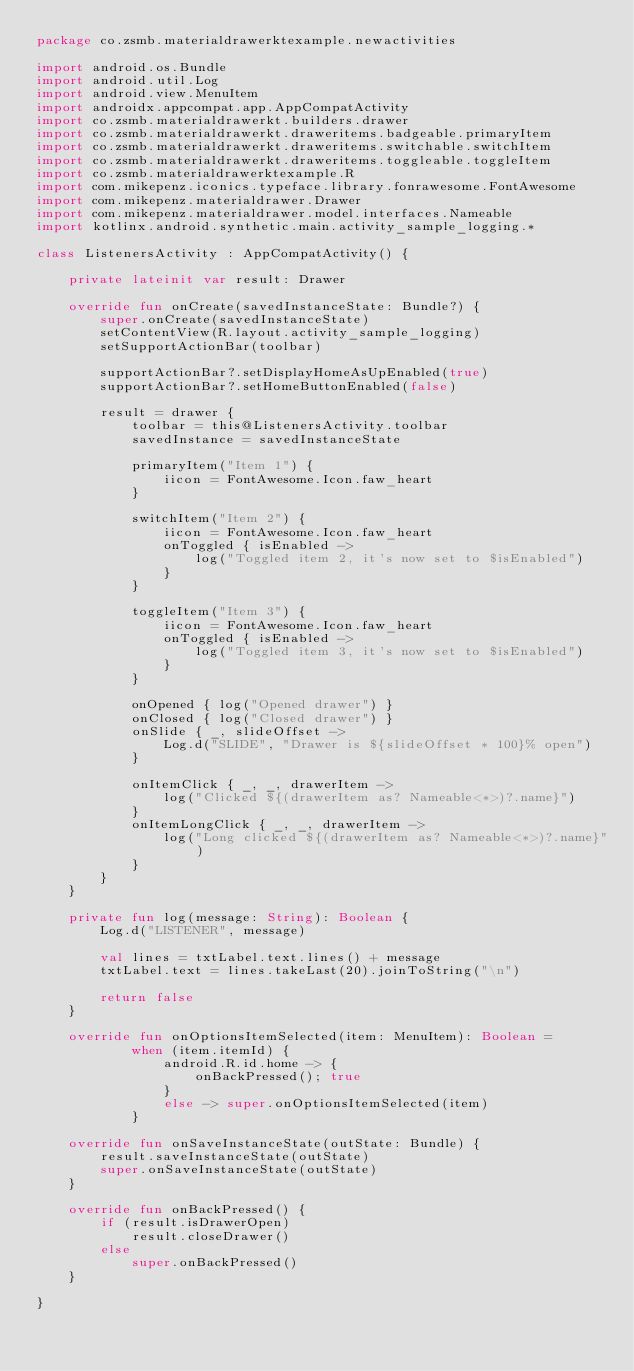Convert code to text. <code><loc_0><loc_0><loc_500><loc_500><_Kotlin_>package co.zsmb.materialdrawerktexample.newactivities

import android.os.Bundle
import android.util.Log
import android.view.MenuItem
import androidx.appcompat.app.AppCompatActivity
import co.zsmb.materialdrawerkt.builders.drawer
import co.zsmb.materialdrawerkt.draweritems.badgeable.primaryItem
import co.zsmb.materialdrawerkt.draweritems.switchable.switchItem
import co.zsmb.materialdrawerkt.draweritems.toggleable.toggleItem
import co.zsmb.materialdrawerktexample.R
import com.mikepenz.iconics.typeface.library.fonrawesome.FontAwesome
import com.mikepenz.materialdrawer.Drawer
import com.mikepenz.materialdrawer.model.interfaces.Nameable
import kotlinx.android.synthetic.main.activity_sample_logging.*

class ListenersActivity : AppCompatActivity() {

    private lateinit var result: Drawer

    override fun onCreate(savedInstanceState: Bundle?) {
        super.onCreate(savedInstanceState)
        setContentView(R.layout.activity_sample_logging)
        setSupportActionBar(toolbar)

        supportActionBar?.setDisplayHomeAsUpEnabled(true)
        supportActionBar?.setHomeButtonEnabled(false)

        result = drawer {
            toolbar = this@ListenersActivity.toolbar
            savedInstance = savedInstanceState

            primaryItem("Item 1") {
                iicon = FontAwesome.Icon.faw_heart
            }

            switchItem("Item 2") {
                iicon = FontAwesome.Icon.faw_heart
                onToggled { isEnabled ->
                    log("Toggled item 2, it's now set to $isEnabled")
                }
            }

            toggleItem("Item 3") {
                iicon = FontAwesome.Icon.faw_heart
                onToggled { isEnabled ->
                    log("Toggled item 3, it's now set to $isEnabled")
                }
            }

            onOpened { log("Opened drawer") }
            onClosed { log("Closed drawer") }
            onSlide { _, slideOffset ->
                Log.d("SLIDE", "Drawer is ${slideOffset * 100}% open")
            }

            onItemClick { _, _, drawerItem ->
                log("Clicked ${(drawerItem as? Nameable<*>)?.name}")
            }
            onItemLongClick { _, _, drawerItem ->
                log("Long clicked ${(drawerItem as? Nameable<*>)?.name}")
            }
        }
    }

    private fun log(message: String): Boolean {
        Log.d("LISTENER", message)

        val lines = txtLabel.text.lines() + message
        txtLabel.text = lines.takeLast(20).joinToString("\n")

        return false
    }

    override fun onOptionsItemSelected(item: MenuItem): Boolean =
            when (item.itemId) {
                android.R.id.home -> {
                    onBackPressed(); true
                }
                else -> super.onOptionsItemSelected(item)
            }

    override fun onSaveInstanceState(outState: Bundle) {
        result.saveInstanceState(outState)
        super.onSaveInstanceState(outState)
    }

    override fun onBackPressed() {
        if (result.isDrawerOpen)
            result.closeDrawer()
        else
            super.onBackPressed()
    }

}
</code> 